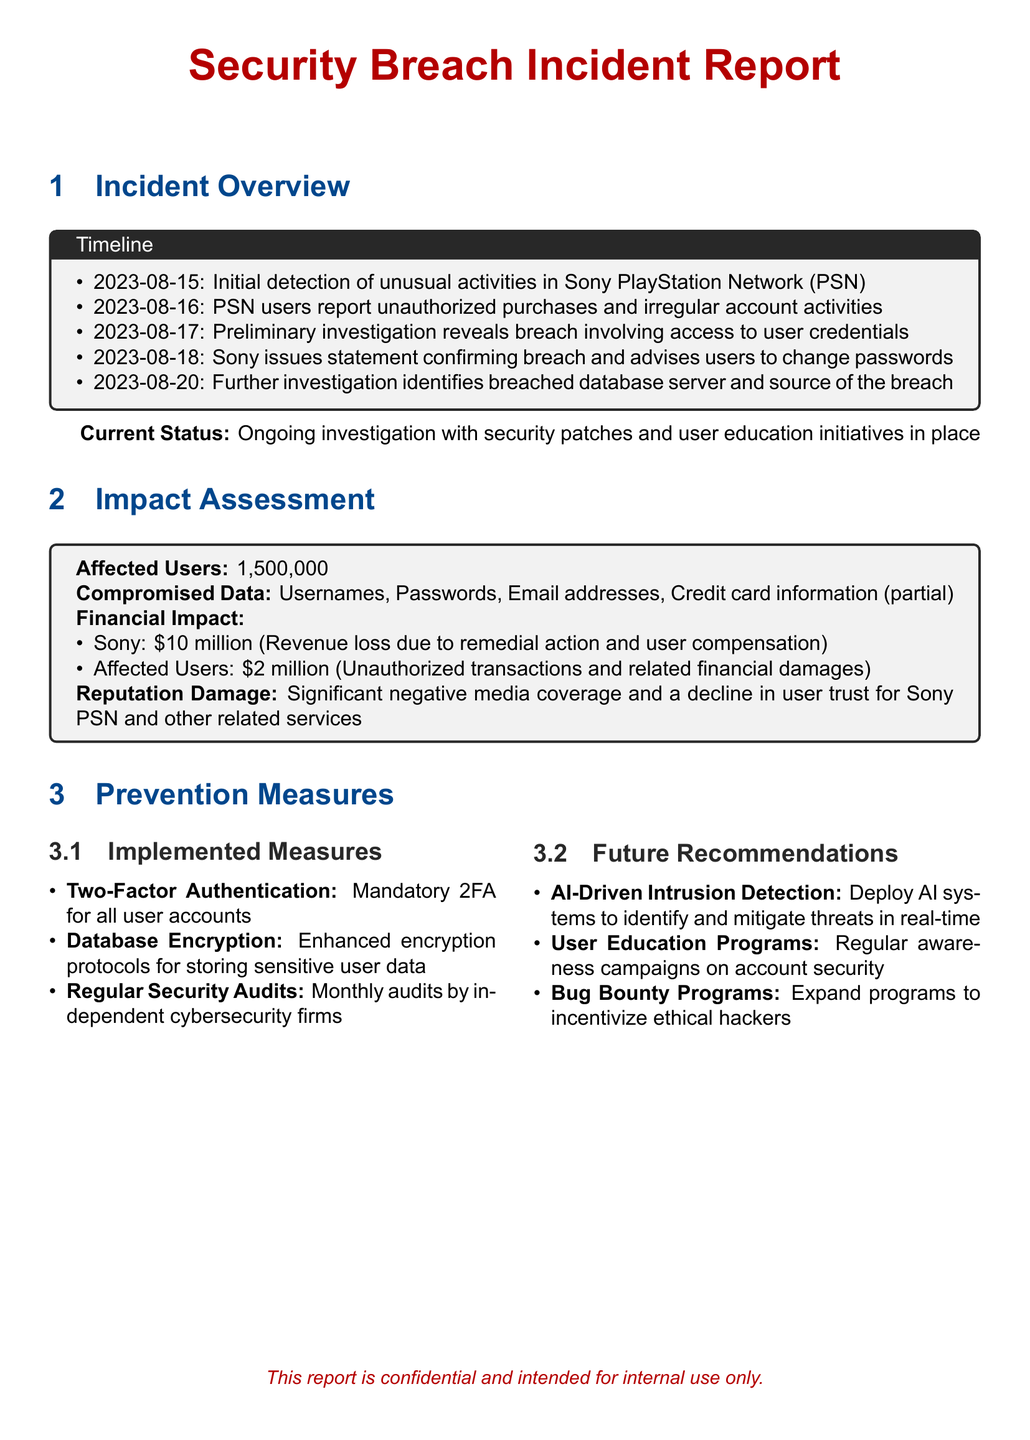What date was the initial detection of unusual activities in PSN? The date of initial detection of unusual activities is mentioned in the timeline.
Answer: 2023-08-15 How many affected users were there? The document states the number of affected users in the impact assessment section.
Answer: 1,500,000 What financial loss did Sony incur due to the breach? The financial impact for Sony is detailed in the assessment section, which states the amount of loss.
Answer: 10 million What is one of the implemented measures for prevention? The implemented measures are listed, indicating steps taken for future protection.
Answer: Two-Factor Authentication What is a noted negative consequence of the breach? The document mentions a consequence in the impact assessment, specifically related to reputation.
Answer: Decline in user trust What is recommended for future prevention? The recommendations for future prevention are included in a section towards the end of the document.
Answer: AI-Driven Intrusion Detection What data was compromised in the breach? The document lists the types of compromised data in the impact assessment.
Answer: Usernames, Passwords, Email addresses, Credit card information (partial) What action did Sony take on August 18, 2023? The timeline details the actions taken by Sony in response to the detected breach on this date.
Answer: Issues statement confirming breach and advises users to change passwords What is the current status of the investigation? The current status is mentioned in the overview section, signifying ongoing efforts.
Answer: Ongoing investigation with security patches and user education initiatives 